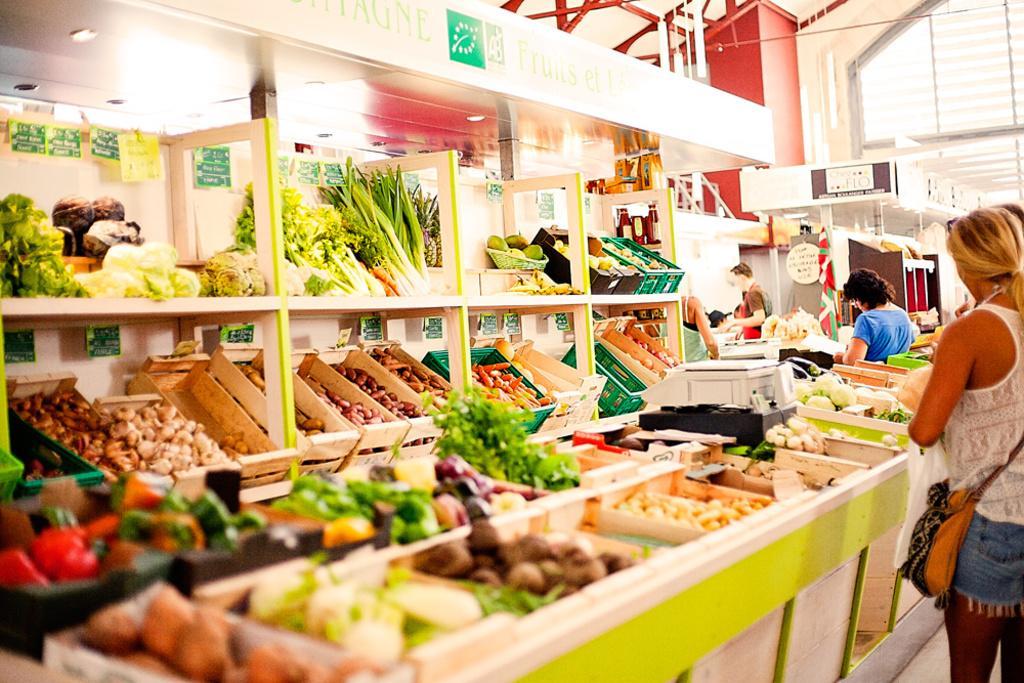Describe this image in one or two sentences. Vegetable store. In this store we can see baskets, racks, vegetables, signboard, price tags, lights and people. In-between of these vegetables there is a weighing machine. 